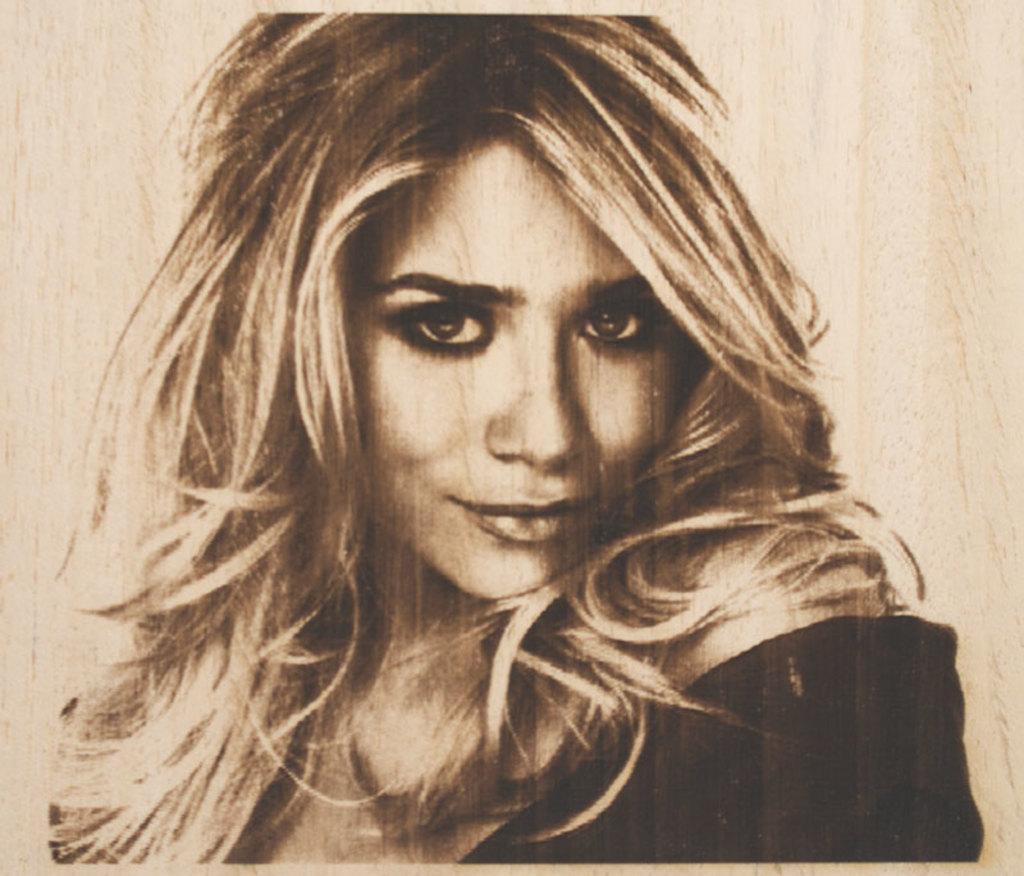Describe this image in one or two sentences. This is a picture of a woman. 